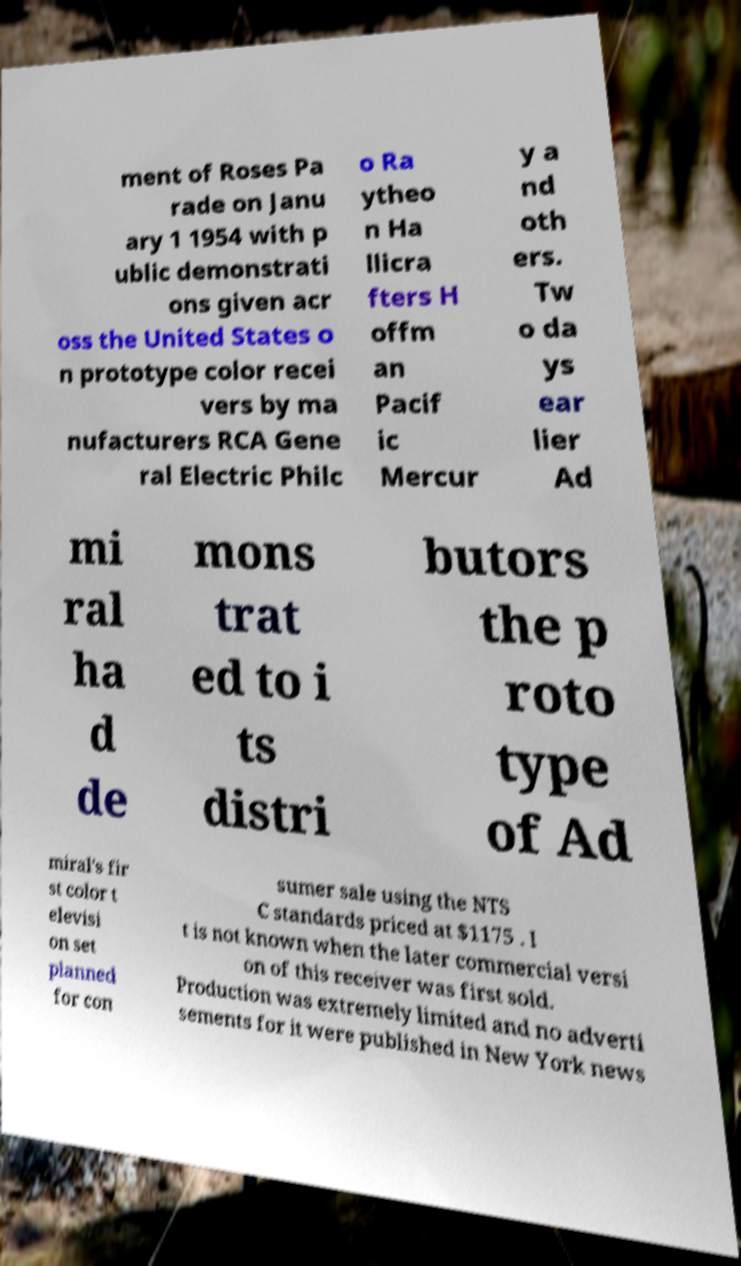Please identify and transcribe the text found in this image. ment of Roses Pa rade on Janu ary 1 1954 with p ublic demonstrati ons given acr oss the United States o n prototype color recei vers by ma nufacturers RCA Gene ral Electric Philc o Ra ytheo n Ha llicra fters H offm an Pacif ic Mercur y a nd oth ers. Tw o da ys ear lier Ad mi ral ha d de mons trat ed to i ts distri butors the p roto type of Ad miral's fir st color t elevisi on set planned for con sumer sale using the NTS C standards priced at $1175 . I t is not known when the later commercial versi on of this receiver was first sold. Production was extremely limited and no adverti sements for it were published in New York news 